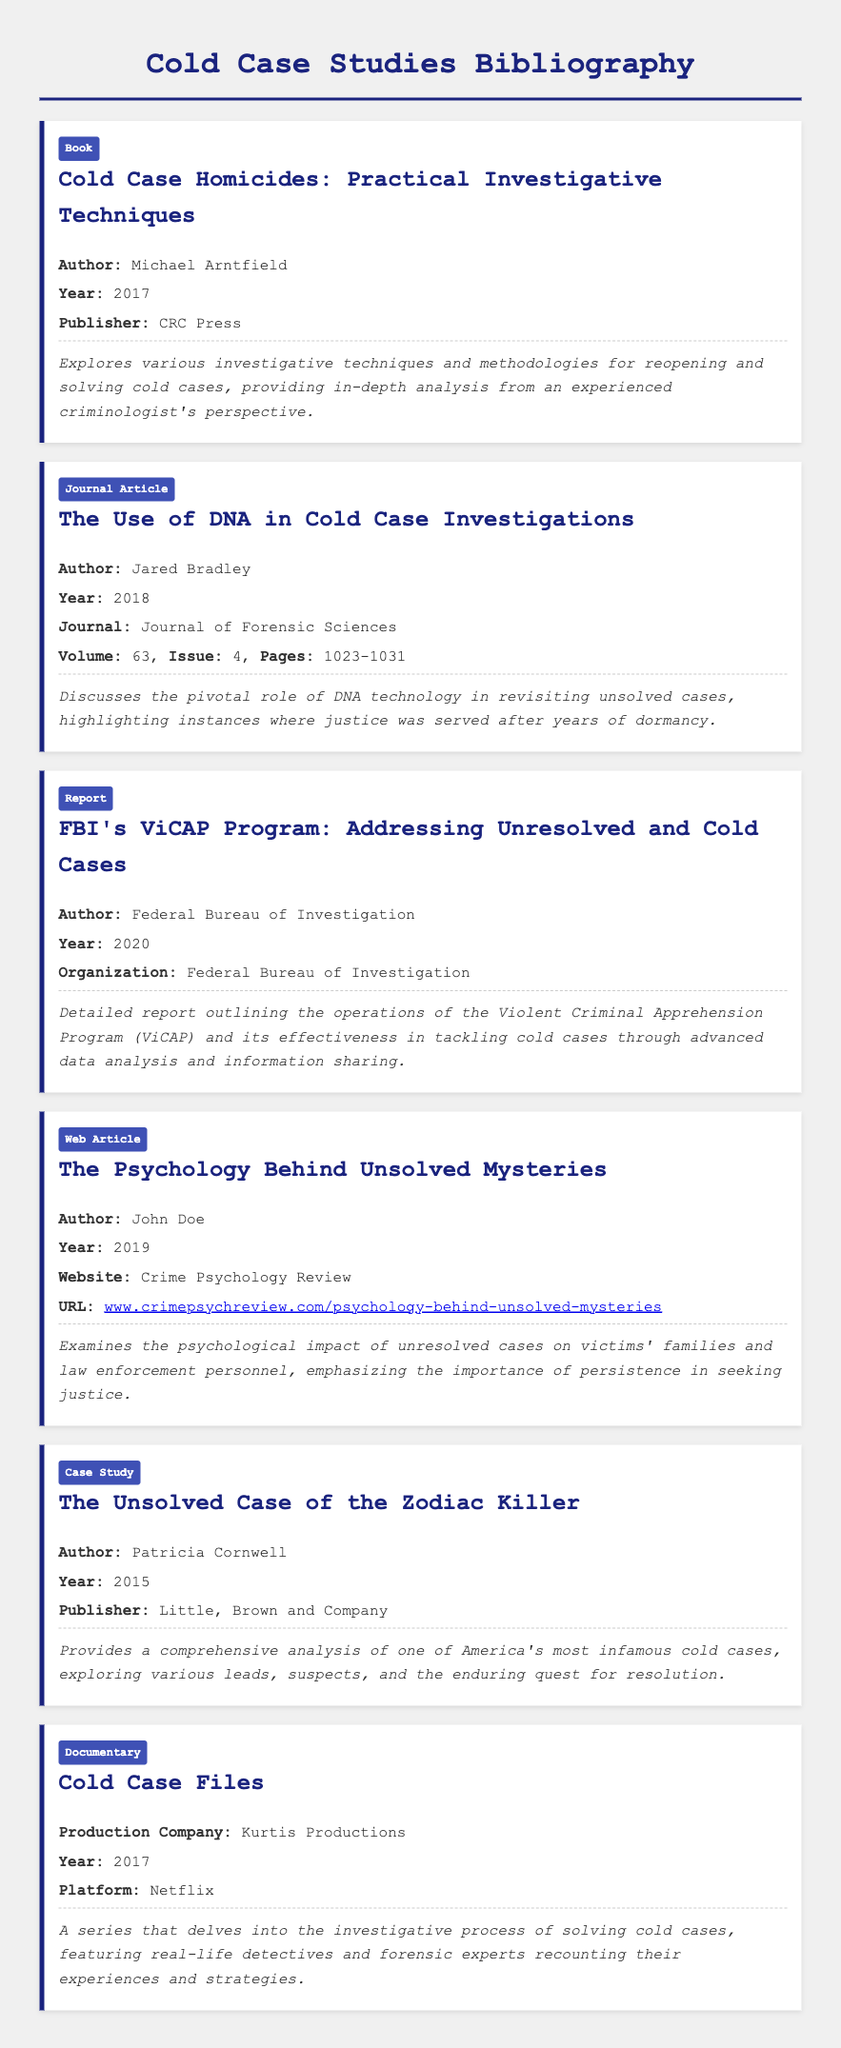What is the title of the book by Michael Arntfield? The title is found in the bibliography item for the book by Michael Arntfield.
Answer: Cold Case Homicides: Practical Investigative Techniques What year was the article by Jared Bradley published? The publication year is listed in the bibliography entry for the journal article by Jared Bradley.
Answer: 2018 Who is the author of "The Unsolved Case of the Zodiac Killer"? The author's name is included in the bibliography entry for this specific case study.
Answer: Patricia Cornwell What type of document is "Cold Case Files"? This information is derived from the document type listed for the entry about "Cold Case Files".
Answer: Documentary Which organization published the report on ViCAP? The name of the organization is mentioned in the bibliography entry for the report about ViCAP.
Answer: Federal Bureau of Investigation What psychological aspect does John Doe's article examine? The summary of the web article indicates the focus on psychological impacts.
Answer: Psychological impact How many pages does Jared Bradley's journal article span? The page numbers are specified in the entry for the journal article by Jared Bradley.
Answer: 1023-1031 What year was the documentary "Cold Case Files" produced? The production year is provided in the bibliography for the documentary "Cold Case Files."
Answer: 2017 